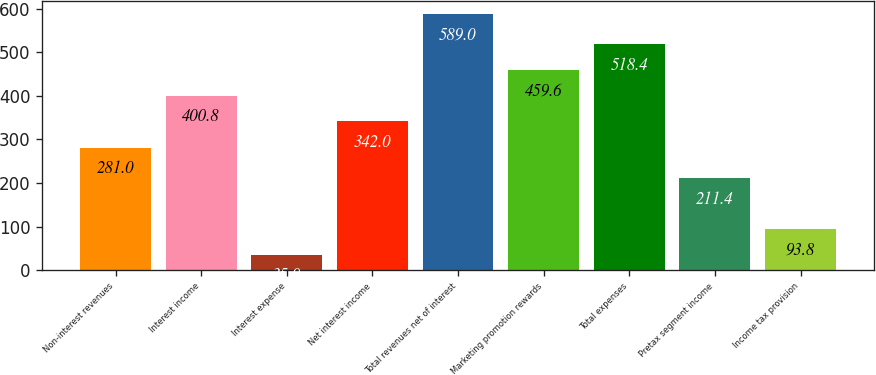<chart> <loc_0><loc_0><loc_500><loc_500><bar_chart><fcel>Non-interest revenues<fcel>Interest income<fcel>Interest expense<fcel>Net interest income<fcel>Total revenues net of interest<fcel>Marketing promotion rewards<fcel>Total expenses<fcel>Pretax segment income<fcel>Income tax provision<nl><fcel>281<fcel>400.8<fcel>35<fcel>342<fcel>589<fcel>459.6<fcel>518.4<fcel>211.4<fcel>93.8<nl></chart> 